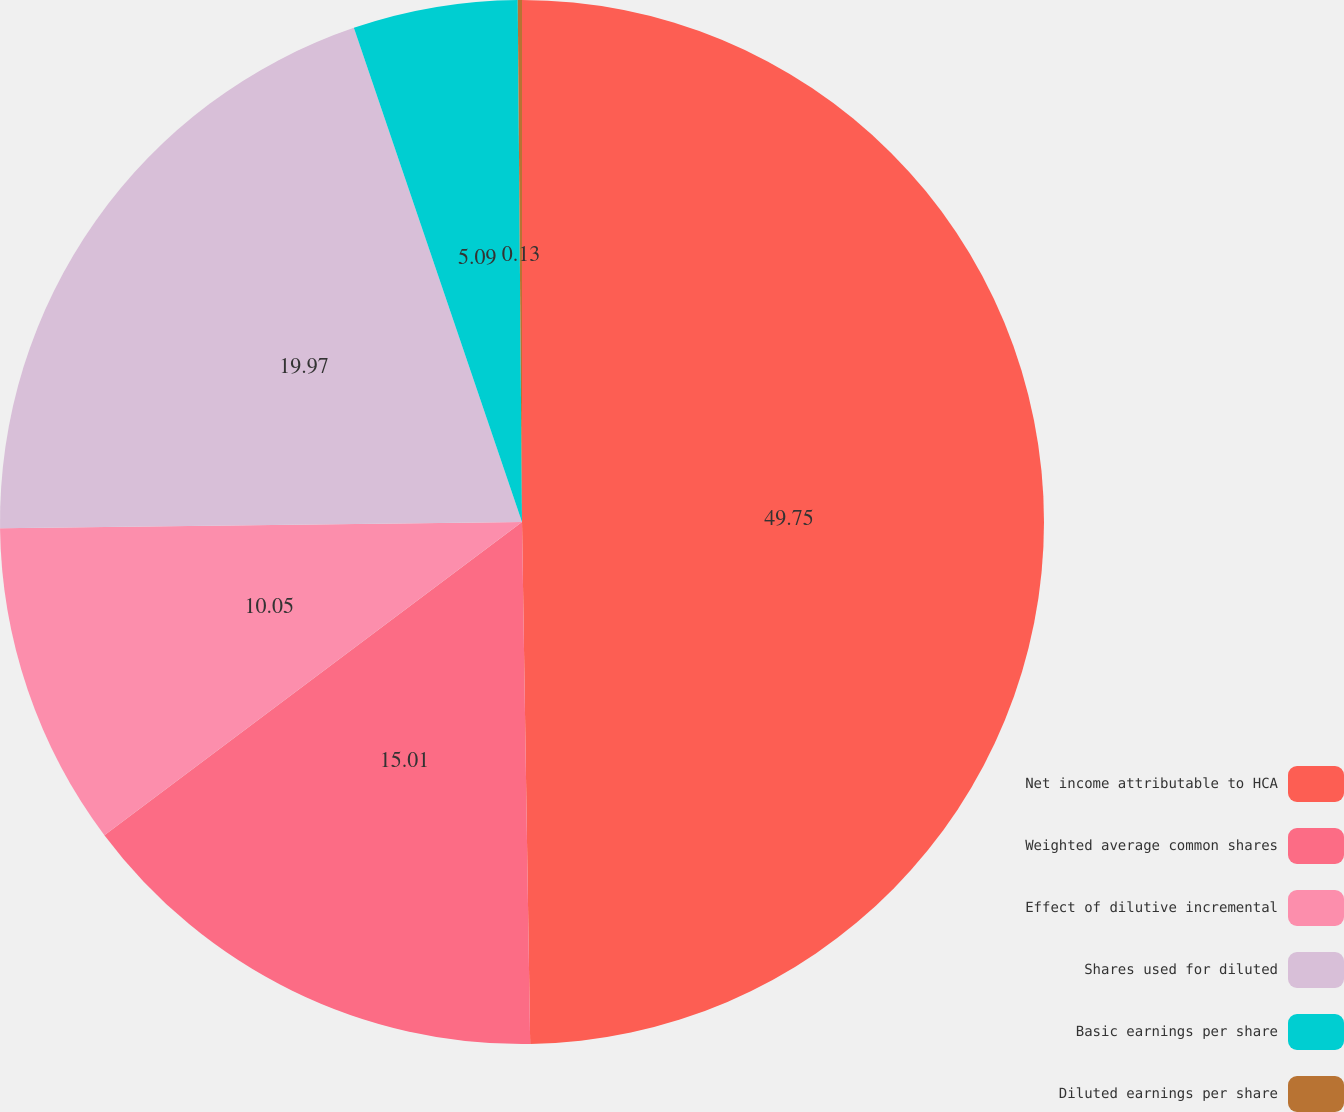Convert chart. <chart><loc_0><loc_0><loc_500><loc_500><pie_chart><fcel>Net income attributable to HCA<fcel>Weighted average common shares<fcel>Effect of dilutive incremental<fcel>Shares used for diluted<fcel>Basic earnings per share<fcel>Diluted earnings per share<nl><fcel>49.75%<fcel>15.01%<fcel>10.05%<fcel>19.97%<fcel>5.09%<fcel>0.13%<nl></chart> 